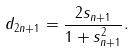<formula> <loc_0><loc_0><loc_500><loc_500>d _ { 2 n + 1 } = \frac { 2 s _ { n + 1 } } { 1 + s _ { n + 1 } ^ { 2 } } .</formula> 